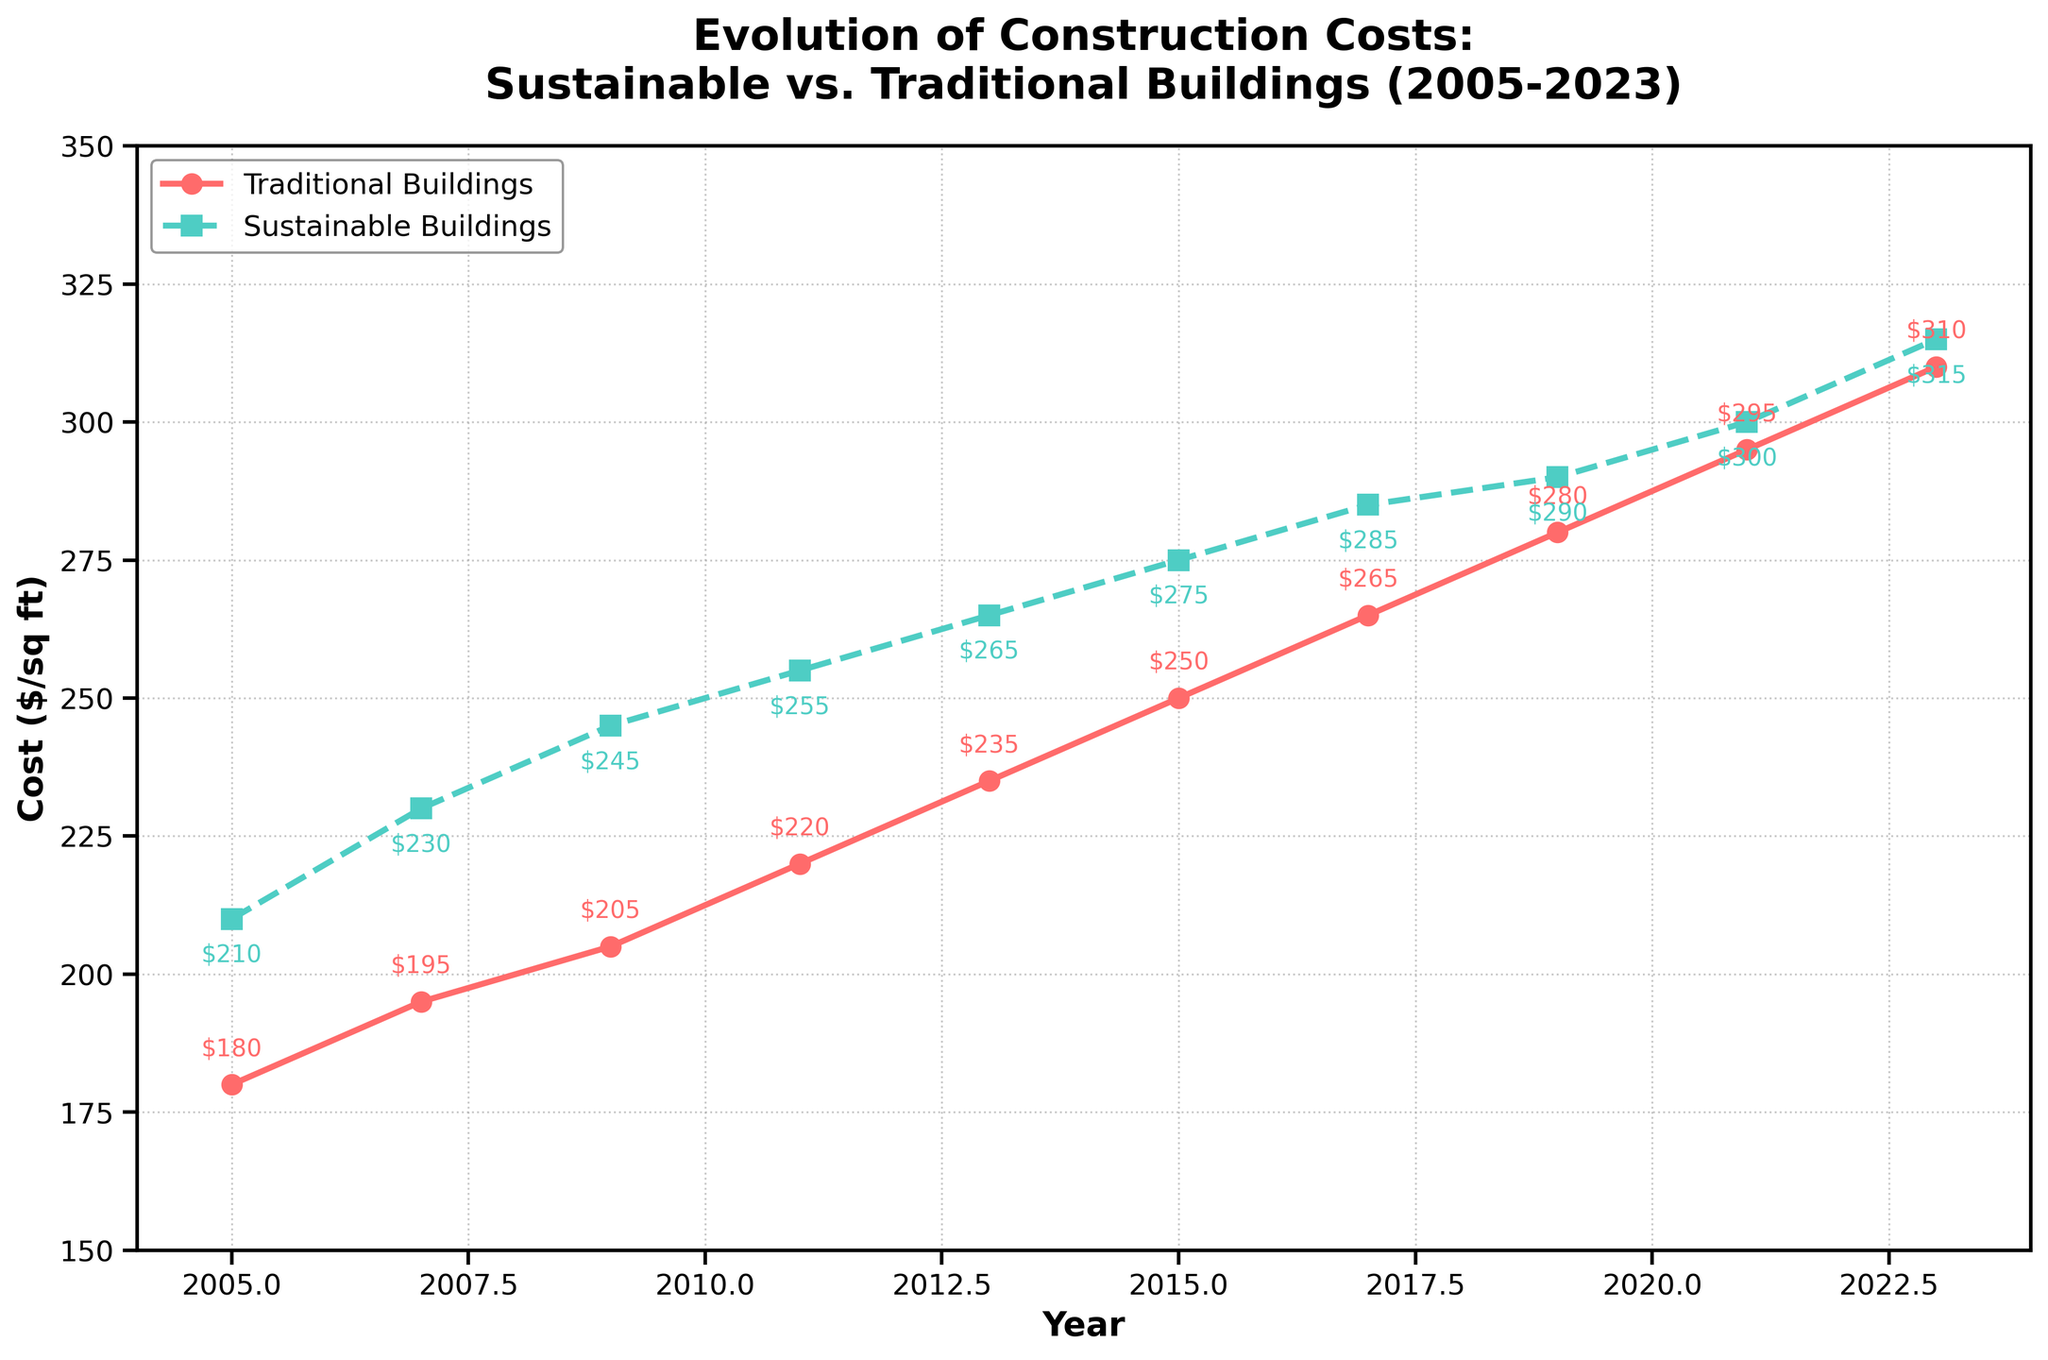What was the cost difference between traditional and sustainable buildings in 2005? The cost difference is calculated by subtracting the cost of traditional buildings from the cost of sustainable buildings for the year 2005. That is 210 - 180.
Answer: 30 How much did the cost of traditional buildings increase from 2007 to 2021? The increase is calculated by subtracting the cost of traditional buildings in 2007 from the cost in 2021. That is 295 - 195.
Answer: 100 In which year did traditional buildings surpass $250 per square foot? By looking at the plotted line for traditional buildings, we observe that it surpasses $250 per square foot in the year 2015.
Answer: 2015 Which type of building had the higher average yearly increase in costs from 2005 to 2023? First, calculate the total increase for each type of building: Traditional buildings: 310 - 180 = 130. Sustainable buildings: 315 - 210 = 105. Then, calculate the number of years: 2023 - 2005 = 18. Finally, compute the yearly increases: Traditional: 130 ÷ 18 ≈ 7.22. Sustainable: 105 ÷ 18 ≈ 5.83. Thus, traditional buildings had a higher average yearly increase.
Answer: Traditional buildings In which year did the costs for both types of buildings reach their maximum difference? By examining the plot, we observe the maximum vertical distance between the two lines, which appears largest in 2005 and 2007, with the difference being 30 for both.
Answer: 2005 and 2007 Which type of building had a more consistent cost increase trend over time? By visually comparing the lines for each type of building, the line for sustainable buildings is smoother with less fluctuation, indicating a more consistent trend.
Answer: Sustainable buildings What's the average cost of sustainable buildings from 2005 to 2023? The average cost is calculated by summing the costs for sustainable buildings from 2005 to 2023 and dividing by the number of data points. (210 + 230 + 245 + 255 + 265 + 275 + 285 + 290 + 300 + 315) ÷ 10 = 267.
Answer: 267 Did sustainable buildings ever have a lower cost than traditional buildings at any point in the data provided? By examining the plotted lines, we see that the line for sustainable buildings is consistently above the line for traditional buildings, indicating that sustainable buildings never had a lower cost.
Answer: No By how much did the cost for sustainable buildings increase between 2005 and 2023? The increase is calculated by subtracting the cost of sustainable buildings in 2005 from that in 2023. That is 315 - 210.
Answer: 105 When was the smallest difference in cost between sustainable and traditional buildings recorded? By examining the plot, we observe that the smallest difference between the two lines is in 2023, where the difference is 315 - 310.
Answer: 2023 